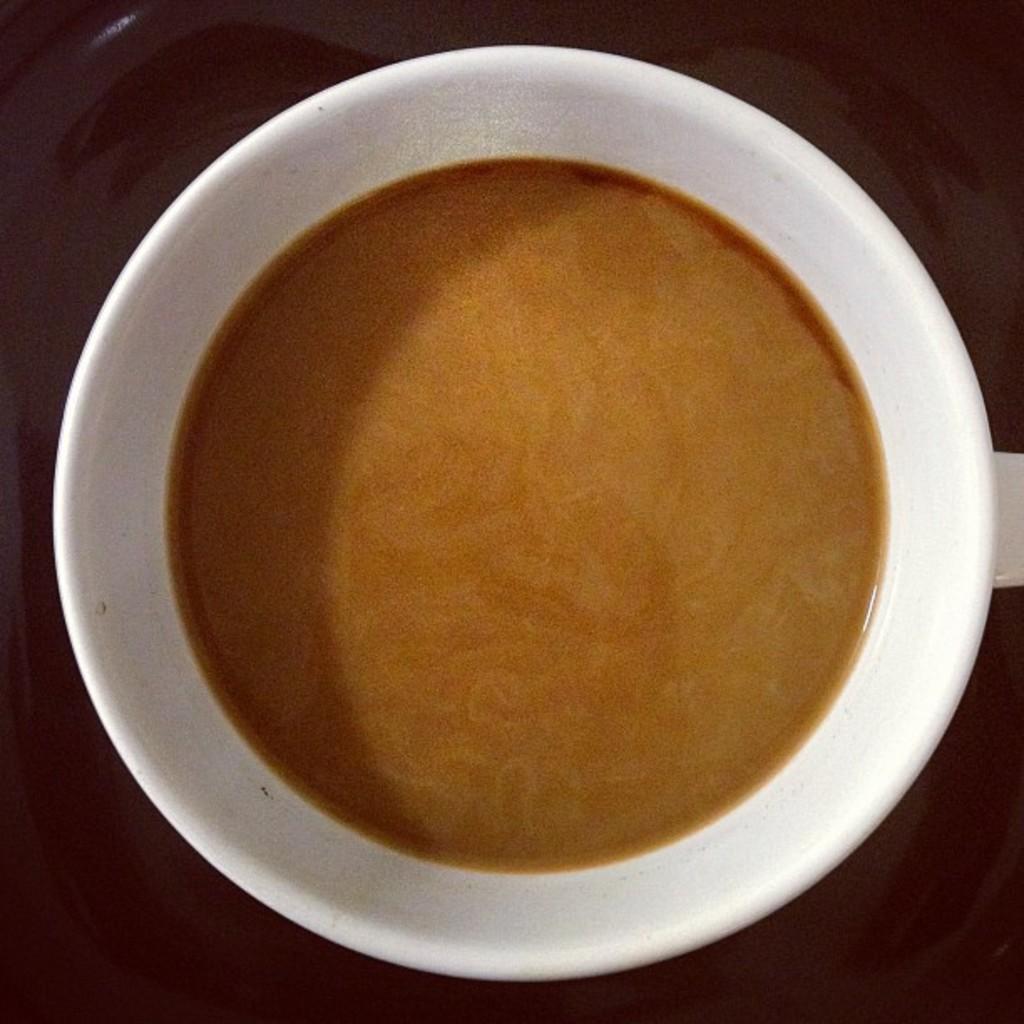Can you describe this image briefly? This is the tea in a white color cup. 